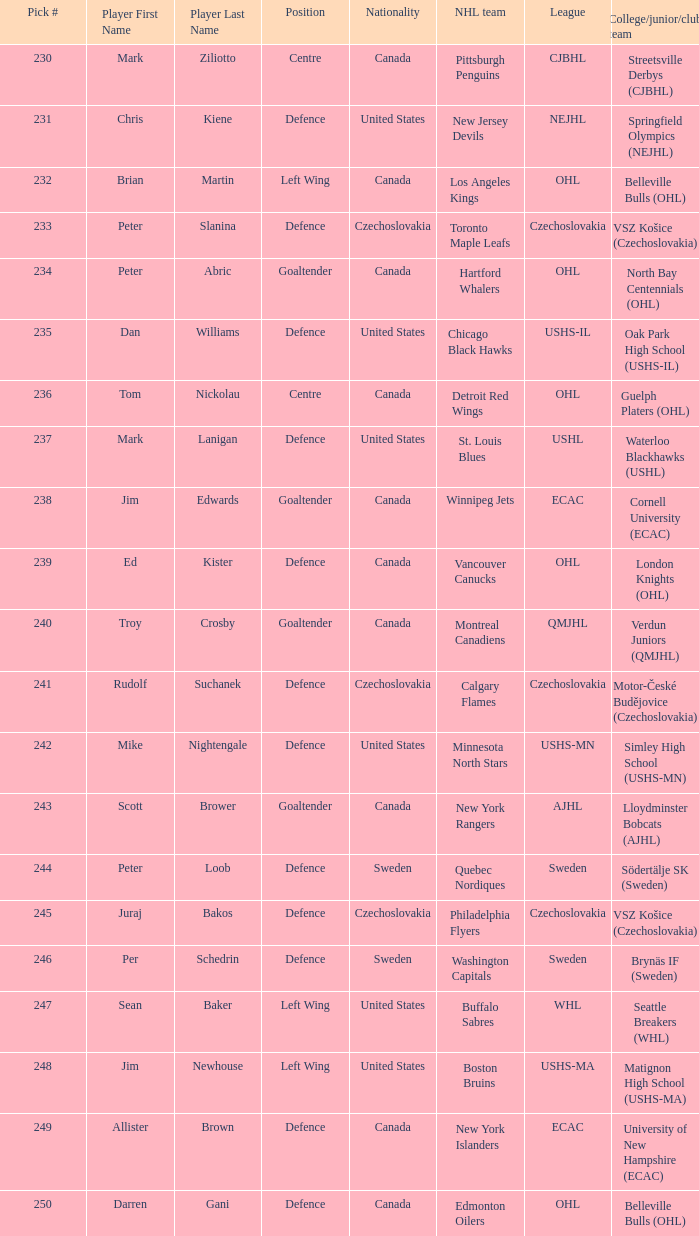Which draft number did the new jersey devils get? 231.0. 